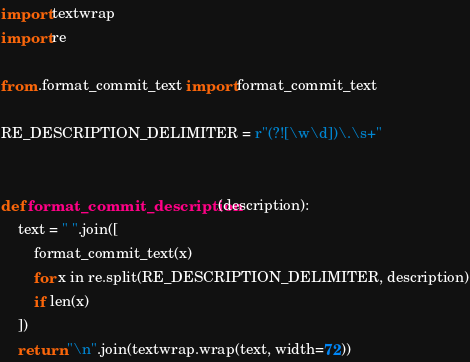Convert code to text. <code><loc_0><loc_0><loc_500><loc_500><_Python_>import textwrap
import re

from .format_commit_text import format_commit_text

RE_DESCRIPTION_DELIMITER = r"(?![\w\d])\.\s+"


def format_commit_description(description):
    text = " ".join([
        format_commit_text(x)
        for x in re.split(RE_DESCRIPTION_DELIMITER, description)
        if len(x)
    ])
    return "\n".join(textwrap.wrap(text, width=72))

</code> 